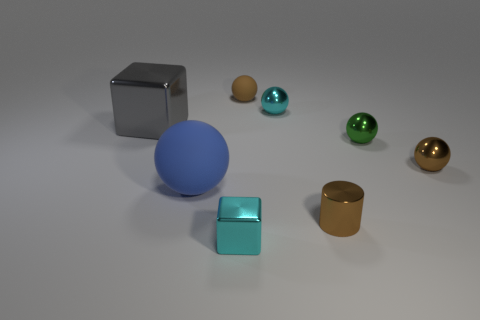There is a cyan metal object that is in front of the large gray thing; what shape is it? The cyan object appears to be a perfectly shaped cube, characterized by its six equal square faces and edges that come together at right angles, providing it with a symmetrical and regular geometry. 